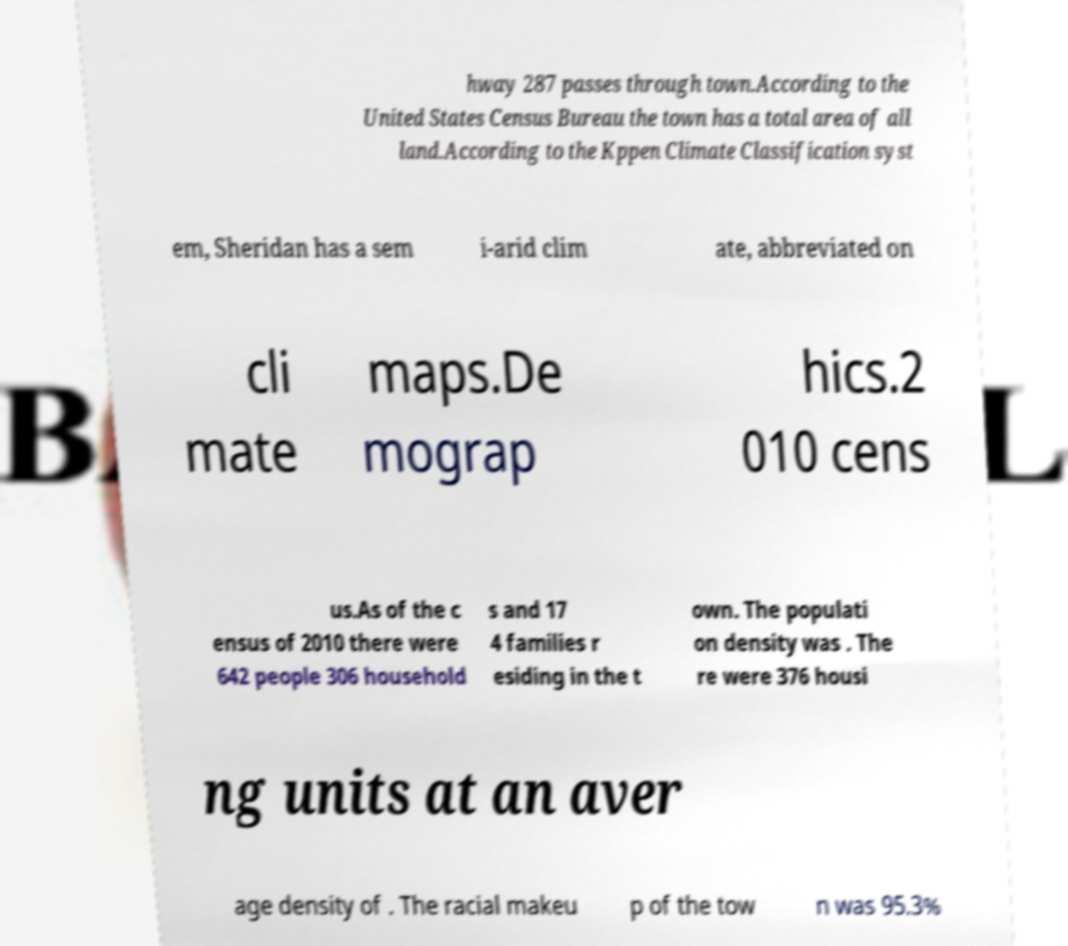There's text embedded in this image that I need extracted. Can you transcribe it verbatim? hway 287 passes through town.According to the United States Census Bureau the town has a total area of all land.According to the Kppen Climate Classification syst em, Sheridan has a sem i-arid clim ate, abbreviated on cli mate maps.De mograp hics.2 010 cens us.As of the c ensus of 2010 there were 642 people 306 household s and 17 4 families r esiding in the t own. The populati on density was . The re were 376 housi ng units at an aver age density of . The racial makeu p of the tow n was 95.3% 